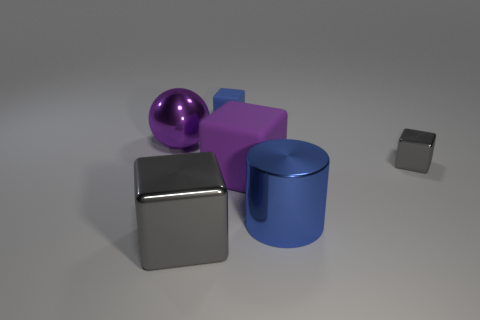Subtract all tiny metal cubes. How many cubes are left? 3 Subtract all blue cubes. How many cubes are left? 3 Subtract all blocks. How many objects are left? 2 Subtract 1 cylinders. How many cylinders are left? 0 Subtract all brown spheres. Subtract all brown cubes. How many spheres are left? 1 Subtract all green blocks. How many gray balls are left? 0 Subtract all big gray objects. Subtract all cylinders. How many objects are left? 4 Add 5 big purple matte blocks. How many big purple matte blocks are left? 6 Add 4 purple spheres. How many purple spheres exist? 5 Add 4 tiny brown balls. How many objects exist? 10 